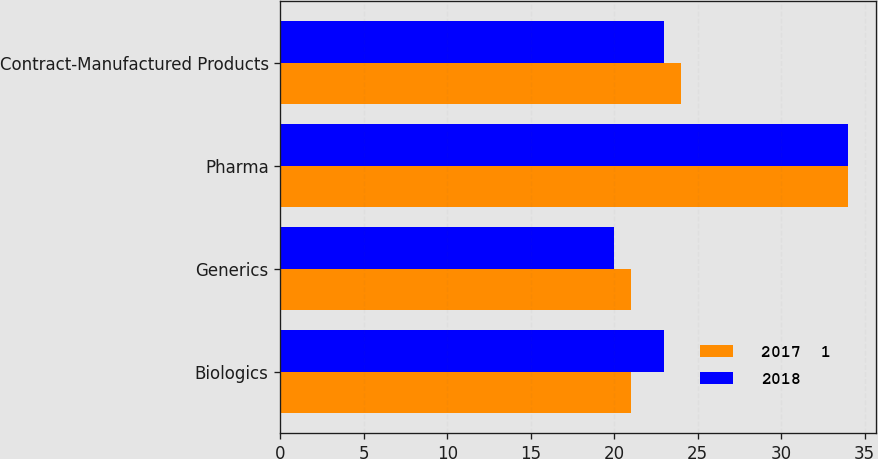<chart> <loc_0><loc_0><loc_500><loc_500><stacked_bar_chart><ecel><fcel>Biologics<fcel>Generics<fcel>Pharma<fcel>Contract-Manufactured Products<nl><fcel>2017  1<fcel>21<fcel>21<fcel>34<fcel>24<nl><fcel>2018<fcel>23<fcel>20<fcel>34<fcel>23<nl></chart> 